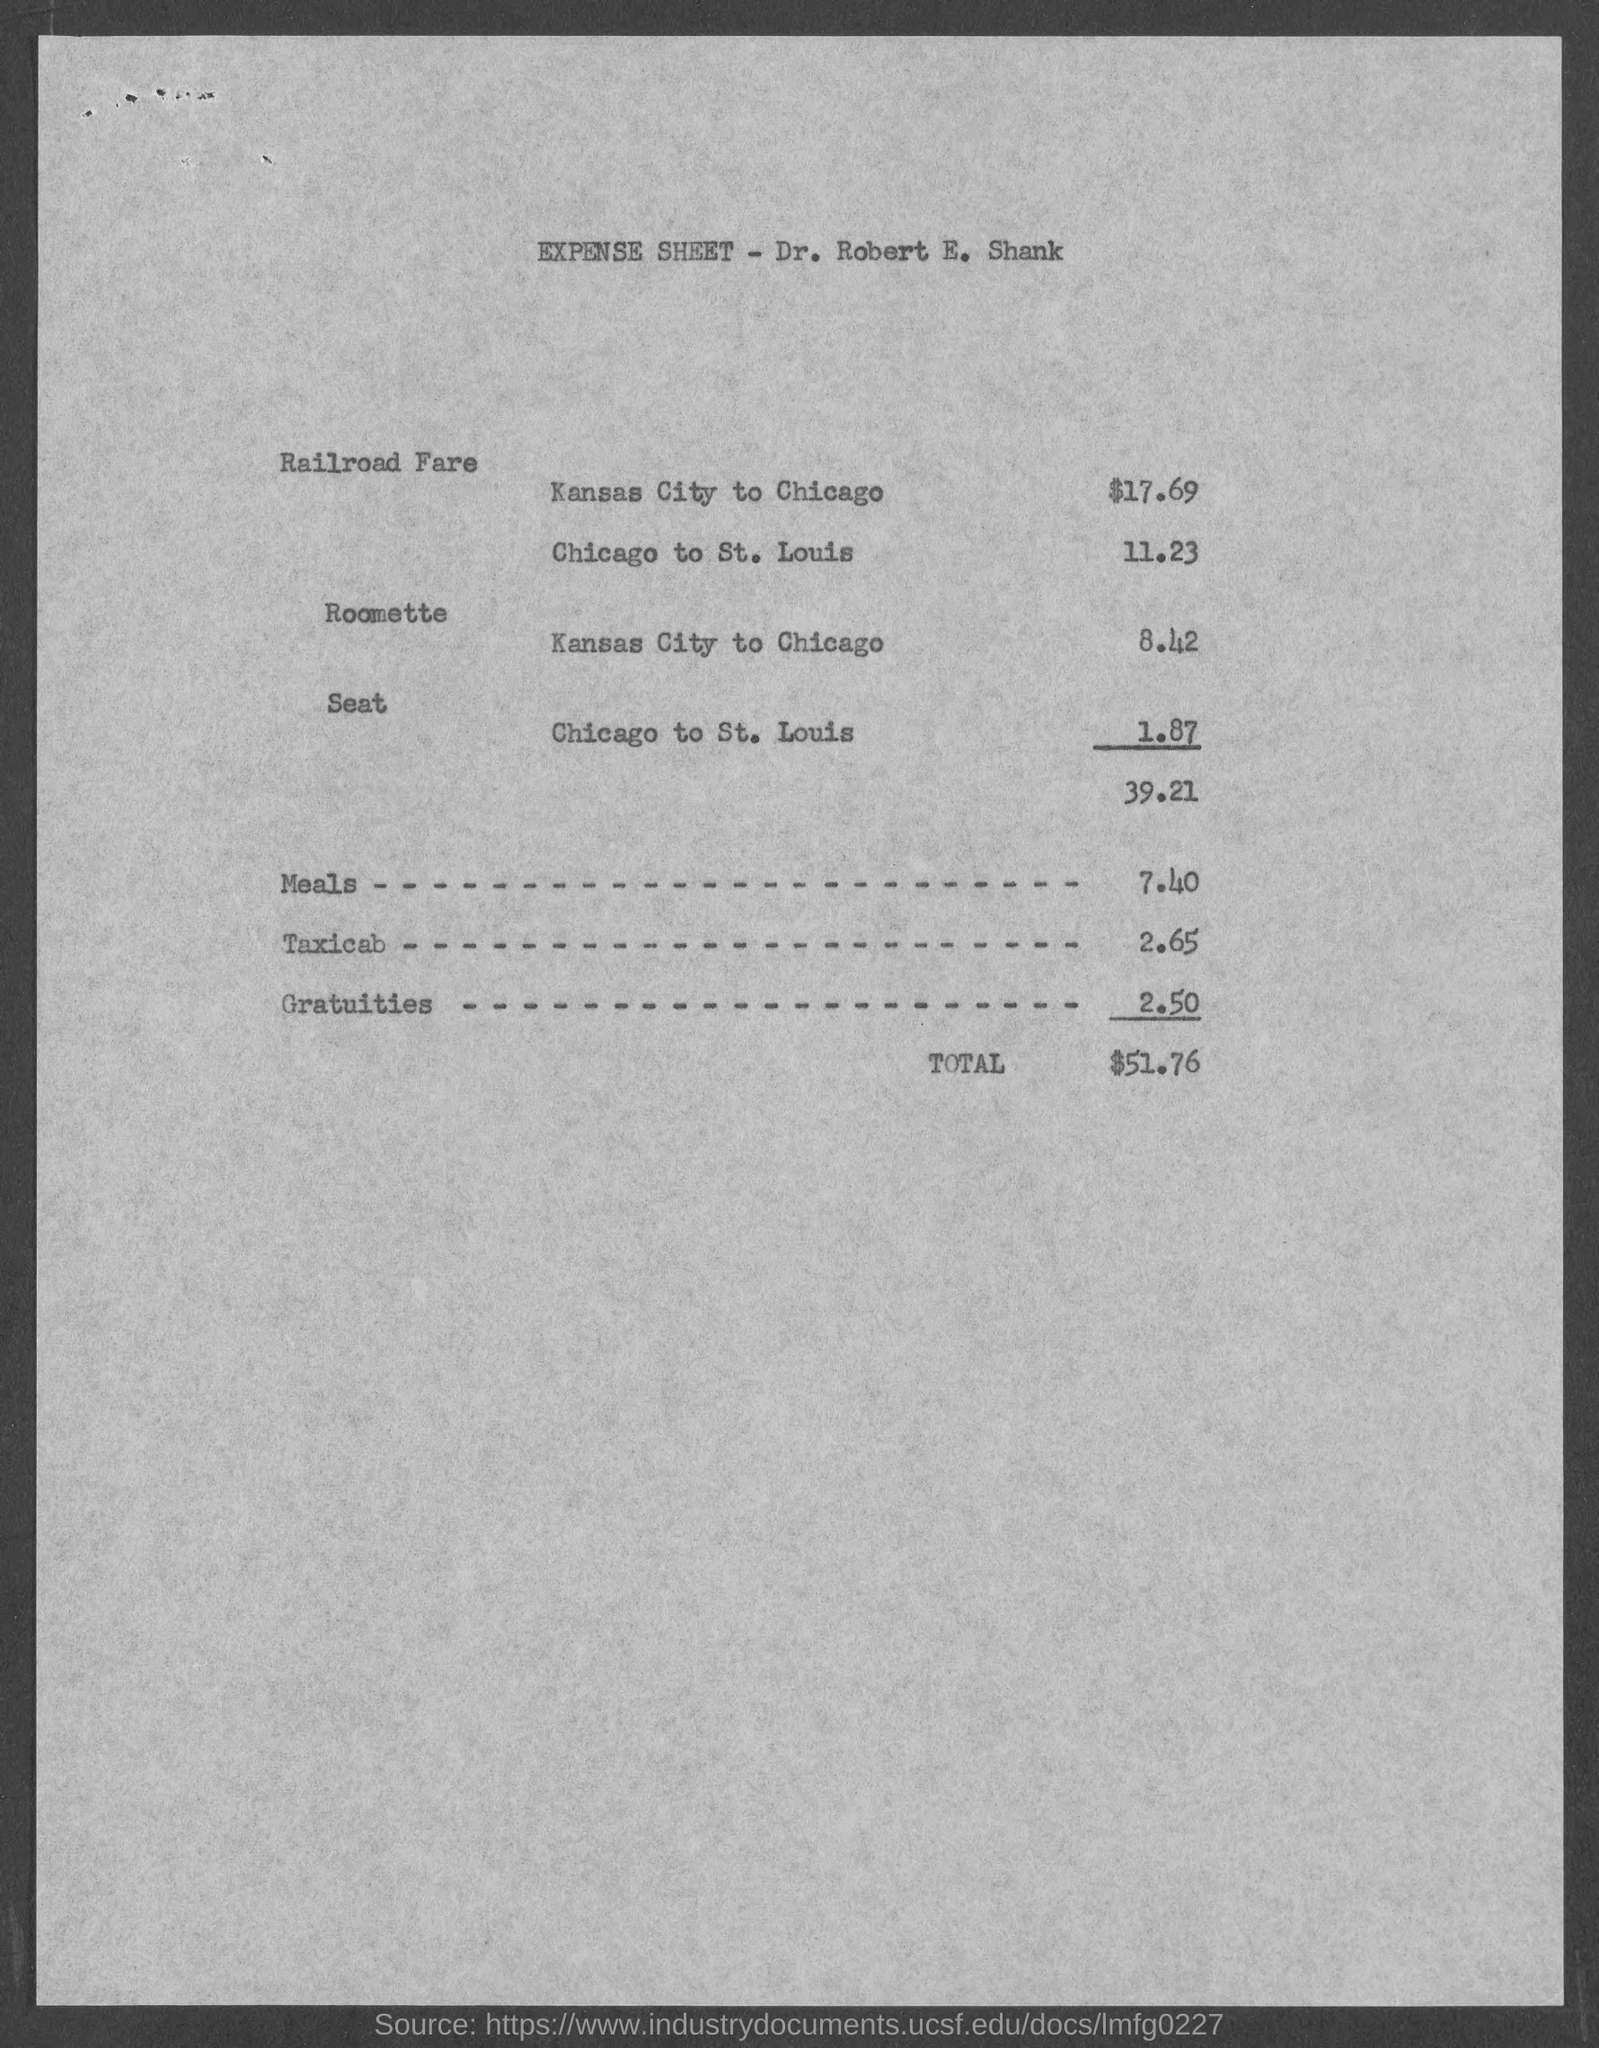Expense sheet is given by whom ?
Your answer should be compact. Dr. Robert E. Shank. How much is the amount for meals
Provide a succinct answer. $ 7.40. How much is the amount for taxi cab
Offer a very short reply. 2.65. How much is the amount for gratuities
Your answer should be compact. $ 2.50. How much is the railroad dare from kansas city to chicago
Your answer should be compact. $17.69. How much is the railroad fare chicago to st. louis
Your answer should be very brief. 11.23. How much is the roomette  from kansas city to chicago
Your answer should be very brief. 8.42. How much is the seat fare from Chicago to St. Louis ?
Ensure brevity in your answer.  $ 1.87. 